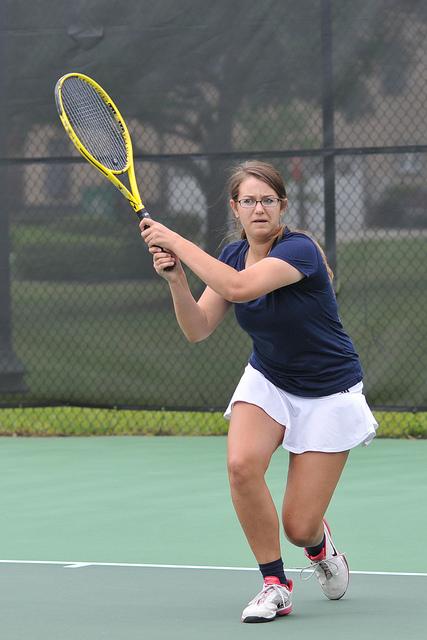What sport is the woman playing?
Be succinct. Tennis. Is this woman famous?
Be succinct. No. Is she wearing a cap?
Be succinct. No. What color are the woman's shorts?
Be succinct. White. 